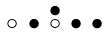<formula> <loc_0><loc_0><loc_500><loc_500>\begin{smallmatrix} & & \bullet \\ \circ & \bullet & \circ & \bullet & \bullet & \\ \end{smallmatrix}</formula> 